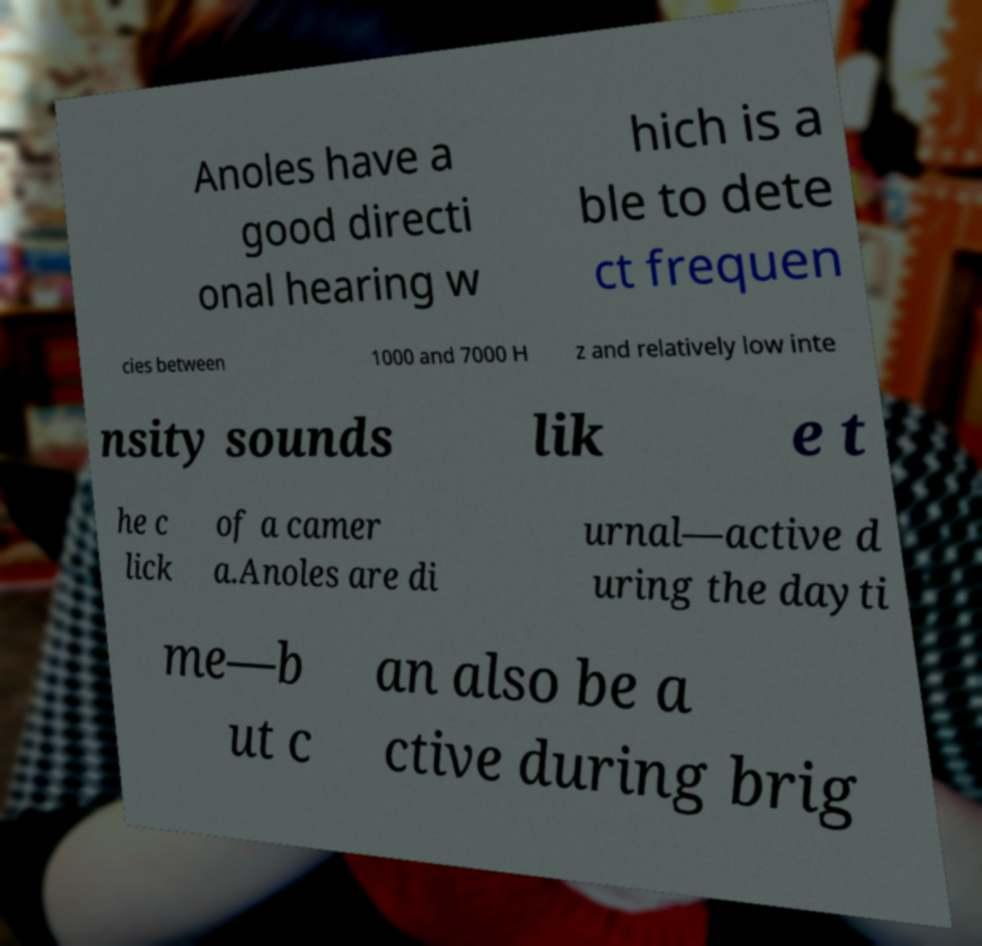Can you accurately transcribe the text from the provided image for me? Anoles have a good directi onal hearing w hich is a ble to dete ct frequen cies between 1000 and 7000 H z and relatively low inte nsity sounds lik e t he c lick of a camer a.Anoles are di urnal—active d uring the dayti me—b ut c an also be a ctive during brig 